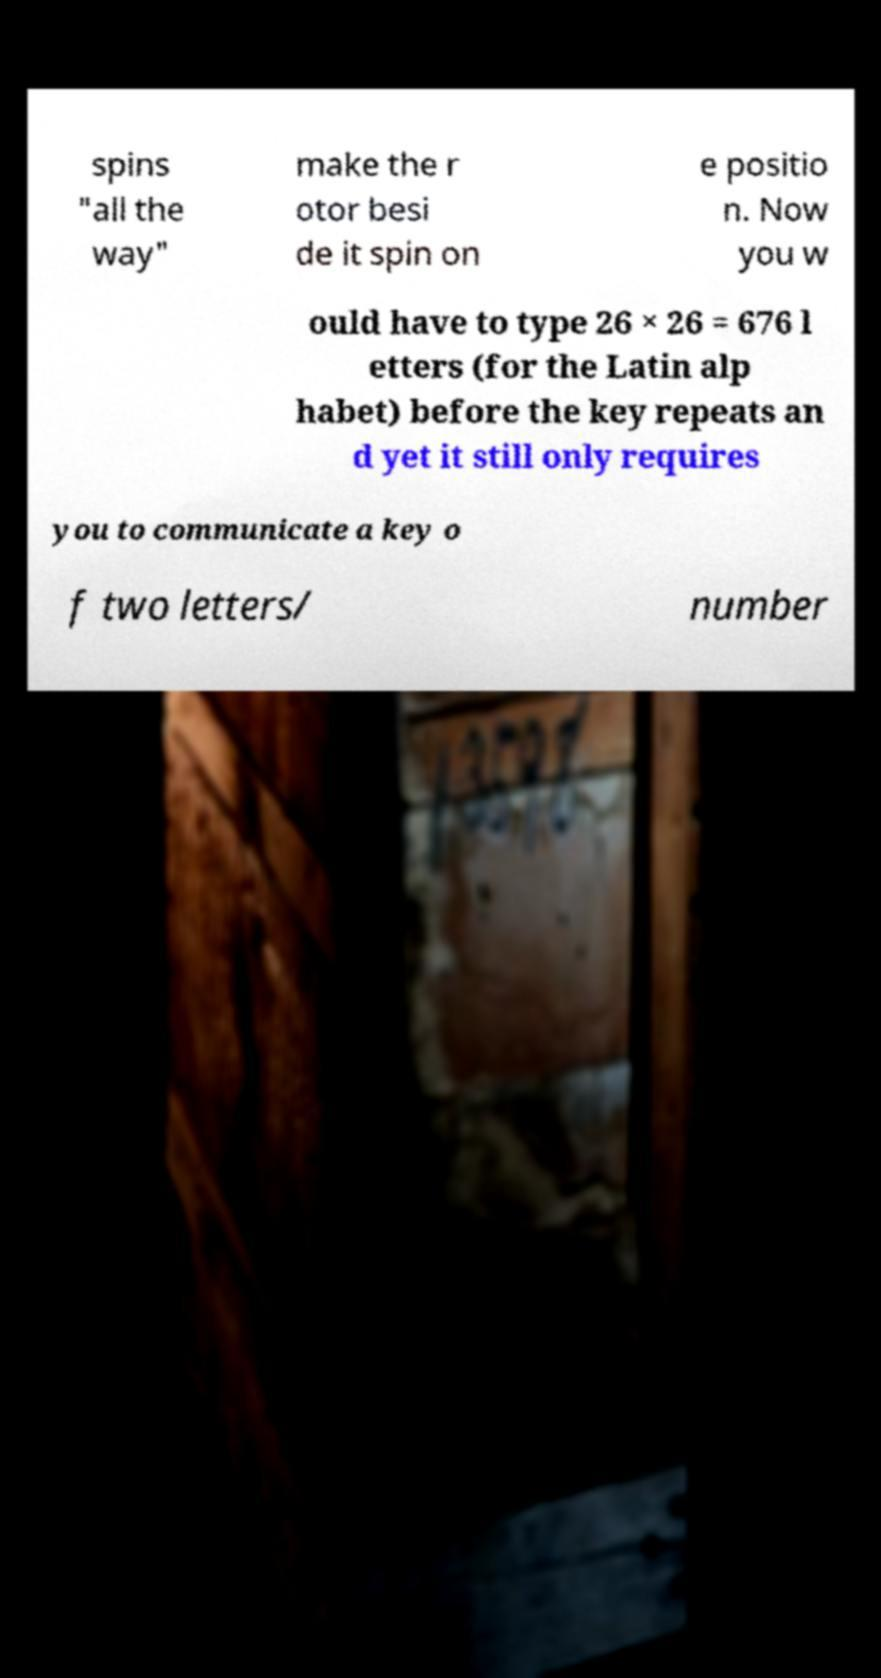Could you extract and type out the text from this image? spins "all the way" make the r otor besi de it spin on e positio n. Now you w ould have to type 26 × 26 = 676 l etters (for the Latin alp habet) before the key repeats an d yet it still only requires you to communicate a key o f two letters/ number 